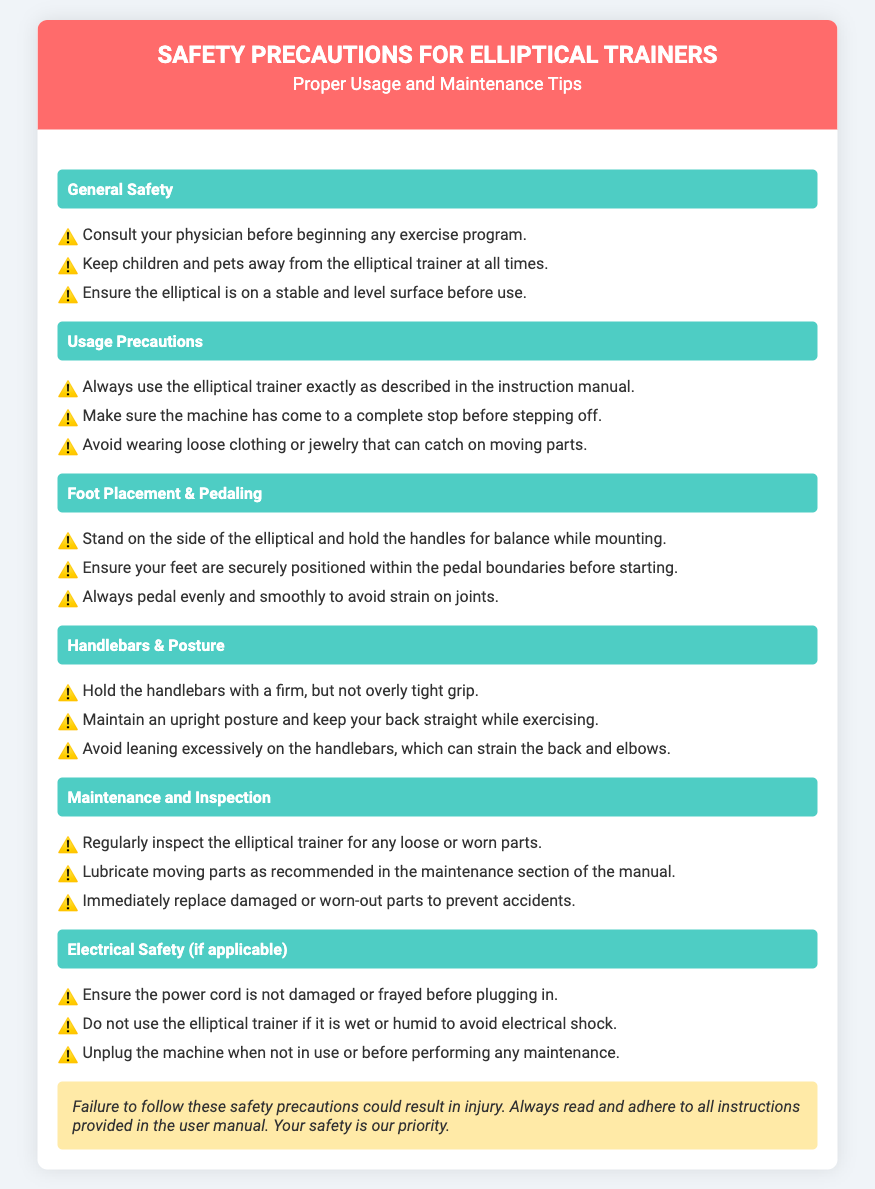What should you do before starting an exercise program? The document advises consulting your physician before beginning any exercise program.
Answer: Consult your physician What should you avoid wearing during use? The document states to avoid wearing loose clothing or jewelry that can catch on moving parts.
Answer: Loose clothing or jewelry What should be inspected regularly? The document mentions that the elliptical trainer should be regularly inspected for any loose or worn parts.
Answer: Loose or worn parts What is recommended for your feet before starting? The document indicates that your feet should be securely positioned within the pedal boundaries before starting.
Answer: Securely positioned What should you do if the power cord is damaged? The document suggests not using the elliptical trainer if the power cord is damaged or frayed.
Answer: Not use the machine Why is it important to maintain an upright posture? The document states that maintaining an upright posture helps to keep your back straight while exercising.
Answer: To keep back straight What must you do with the machine when not in use? The document specifies to unplug the machine when not in use.
Answer: Unplug the machine How should you hold the handlebars? The document advises holding the handlebars with a firm, but not overly tight grip.
Answer: Firm grip What could occur if safety precautions are not followed? The document warns that failure to follow these safety precautions could result in injury.
Answer: Injury What maintenance tip is given about moving parts? The document mentions to lubricate moving parts as recommended in the maintenance section of the manual.
Answer: Lubricate moving parts 